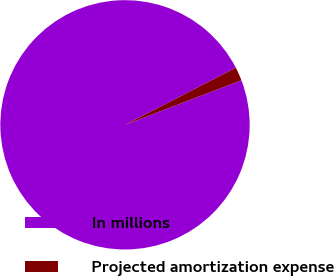Convert chart. <chart><loc_0><loc_0><loc_500><loc_500><pie_chart><fcel>In millions<fcel>Projected amortization expense<nl><fcel>98.25%<fcel>1.75%<nl></chart> 